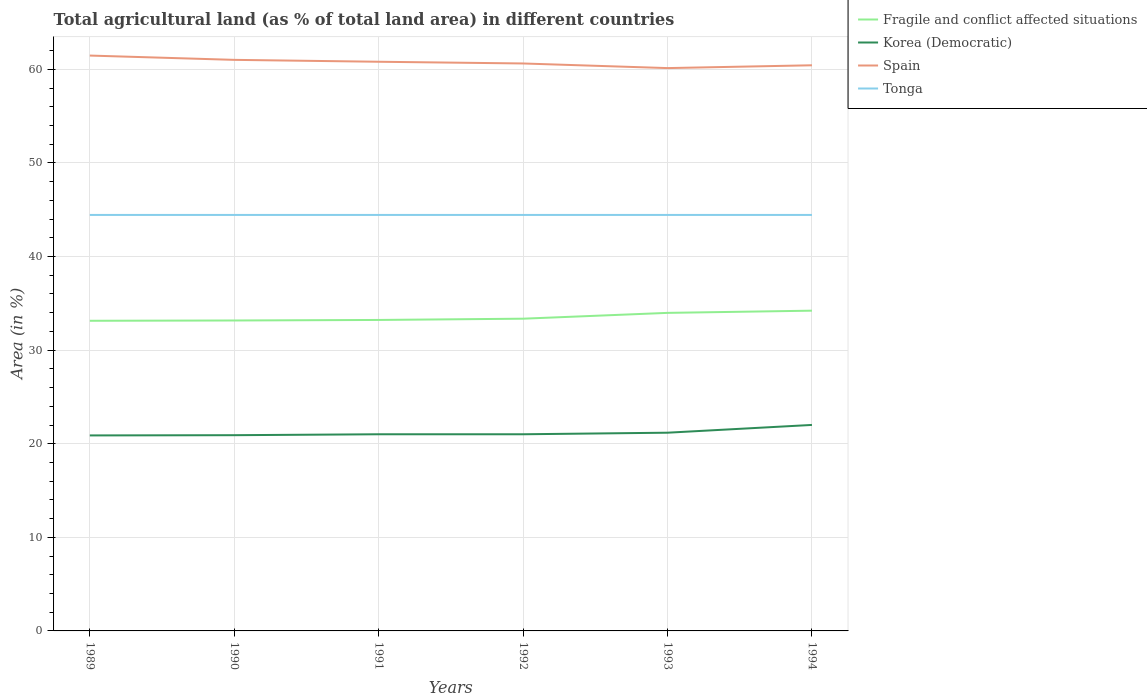Does the line corresponding to Tonga intersect with the line corresponding to Korea (Democratic)?
Keep it short and to the point. No. Is the number of lines equal to the number of legend labels?
Keep it short and to the point. Yes. Across all years, what is the maximum percentage of agricultural land in Fragile and conflict affected situations?
Ensure brevity in your answer.  33.13. In which year was the percentage of agricultural land in Fragile and conflict affected situations maximum?
Your response must be concise. 1989. What is the total percentage of agricultural land in Korea (Democratic) in the graph?
Give a very brief answer. -0.29. What is the difference between the highest and the second highest percentage of agricultural land in Tonga?
Your answer should be compact. 0. Is the percentage of agricultural land in Fragile and conflict affected situations strictly greater than the percentage of agricultural land in Korea (Democratic) over the years?
Provide a short and direct response. No. Are the values on the major ticks of Y-axis written in scientific E-notation?
Keep it short and to the point. No. Does the graph contain any zero values?
Keep it short and to the point. No. How many legend labels are there?
Keep it short and to the point. 4. What is the title of the graph?
Provide a succinct answer. Total agricultural land (as % of total land area) in different countries. Does "Central Europe" appear as one of the legend labels in the graph?
Your answer should be very brief. No. What is the label or title of the X-axis?
Ensure brevity in your answer.  Years. What is the label or title of the Y-axis?
Provide a succinct answer. Area (in %). What is the Area (in %) in Fragile and conflict affected situations in 1989?
Your response must be concise. 33.13. What is the Area (in %) in Korea (Democratic) in 1989?
Keep it short and to the point. 20.89. What is the Area (in %) in Spain in 1989?
Provide a succinct answer. 61.47. What is the Area (in %) of Tonga in 1989?
Offer a terse response. 44.44. What is the Area (in %) of Fragile and conflict affected situations in 1990?
Provide a short and direct response. 33.17. What is the Area (in %) in Korea (Democratic) in 1990?
Your answer should be compact. 20.91. What is the Area (in %) in Spain in 1990?
Your response must be concise. 61.01. What is the Area (in %) in Tonga in 1990?
Your answer should be compact. 44.44. What is the Area (in %) of Fragile and conflict affected situations in 1991?
Your response must be concise. 33.22. What is the Area (in %) in Korea (Democratic) in 1991?
Keep it short and to the point. 21.01. What is the Area (in %) in Spain in 1991?
Your response must be concise. 60.81. What is the Area (in %) in Tonga in 1991?
Offer a terse response. 44.44. What is the Area (in %) of Fragile and conflict affected situations in 1992?
Provide a short and direct response. 33.36. What is the Area (in %) in Korea (Democratic) in 1992?
Provide a short and direct response. 21.01. What is the Area (in %) of Spain in 1992?
Give a very brief answer. 60.63. What is the Area (in %) of Tonga in 1992?
Offer a terse response. 44.44. What is the Area (in %) in Fragile and conflict affected situations in 1993?
Provide a short and direct response. 33.98. What is the Area (in %) in Korea (Democratic) in 1993?
Your answer should be very brief. 21.18. What is the Area (in %) of Spain in 1993?
Offer a very short reply. 60.13. What is the Area (in %) in Tonga in 1993?
Make the answer very short. 44.44. What is the Area (in %) in Fragile and conflict affected situations in 1994?
Make the answer very short. 34.21. What is the Area (in %) of Korea (Democratic) in 1994?
Keep it short and to the point. 22.01. What is the Area (in %) of Spain in 1994?
Ensure brevity in your answer.  60.43. What is the Area (in %) of Tonga in 1994?
Offer a terse response. 44.44. Across all years, what is the maximum Area (in %) in Fragile and conflict affected situations?
Provide a short and direct response. 34.21. Across all years, what is the maximum Area (in %) of Korea (Democratic)?
Ensure brevity in your answer.  22.01. Across all years, what is the maximum Area (in %) in Spain?
Ensure brevity in your answer.  61.47. Across all years, what is the maximum Area (in %) in Tonga?
Keep it short and to the point. 44.44. Across all years, what is the minimum Area (in %) in Fragile and conflict affected situations?
Offer a terse response. 33.13. Across all years, what is the minimum Area (in %) of Korea (Democratic)?
Ensure brevity in your answer.  20.89. Across all years, what is the minimum Area (in %) of Spain?
Give a very brief answer. 60.13. Across all years, what is the minimum Area (in %) in Tonga?
Ensure brevity in your answer.  44.44. What is the total Area (in %) in Fragile and conflict affected situations in the graph?
Your answer should be compact. 201.08. What is the total Area (in %) in Korea (Democratic) in the graph?
Your response must be concise. 127.01. What is the total Area (in %) in Spain in the graph?
Provide a succinct answer. 364.49. What is the total Area (in %) of Tonga in the graph?
Your answer should be compact. 266.67. What is the difference between the Area (in %) of Fragile and conflict affected situations in 1989 and that in 1990?
Your answer should be compact. -0.03. What is the difference between the Area (in %) of Korea (Democratic) in 1989 and that in 1990?
Provide a short and direct response. -0.02. What is the difference between the Area (in %) of Spain in 1989 and that in 1990?
Provide a succinct answer. 0.46. What is the difference between the Area (in %) in Fragile and conflict affected situations in 1989 and that in 1991?
Offer a very short reply. -0.09. What is the difference between the Area (in %) in Korea (Democratic) in 1989 and that in 1991?
Offer a very short reply. -0.12. What is the difference between the Area (in %) in Spain in 1989 and that in 1991?
Ensure brevity in your answer.  0.66. What is the difference between the Area (in %) in Fragile and conflict affected situations in 1989 and that in 1992?
Keep it short and to the point. -0.22. What is the difference between the Area (in %) of Korea (Democratic) in 1989 and that in 1992?
Offer a very short reply. -0.12. What is the difference between the Area (in %) of Spain in 1989 and that in 1992?
Make the answer very short. 0.84. What is the difference between the Area (in %) in Fragile and conflict affected situations in 1989 and that in 1993?
Provide a short and direct response. -0.84. What is the difference between the Area (in %) of Korea (Democratic) in 1989 and that in 1993?
Offer a very short reply. -0.29. What is the difference between the Area (in %) of Spain in 1989 and that in 1993?
Give a very brief answer. 1.34. What is the difference between the Area (in %) in Tonga in 1989 and that in 1993?
Your answer should be compact. 0. What is the difference between the Area (in %) in Fragile and conflict affected situations in 1989 and that in 1994?
Offer a very short reply. -1.08. What is the difference between the Area (in %) of Korea (Democratic) in 1989 and that in 1994?
Offer a terse response. -1.12. What is the difference between the Area (in %) in Spain in 1989 and that in 1994?
Offer a terse response. 1.04. What is the difference between the Area (in %) of Tonga in 1989 and that in 1994?
Provide a short and direct response. 0. What is the difference between the Area (in %) of Fragile and conflict affected situations in 1990 and that in 1991?
Give a very brief answer. -0.06. What is the difference between the Area (in %) of Korea (Democratic) in 1990 and that in 1991?
Make the answer very short. -0.1. What is the difference between the Area (in %) of Spain in 1990 and that in 1991?
Provide a short and direct response. 0.2. What is the difference between the Area (in %) of Fragile and conflict affected situations in 1990 and that in 1992?
Make the answer very short. -0.19. What is the difference between the Area (in %) of Korea (Democratic) in 1990 and that in 1992?
Make the answer very short. -0.1. What is the difference between the Area (in %) in Spain in 1990 and that in 1992?
Make the answer very short. 0.39. What is the difference between the Area (in %) of Tonga in 1990 and that in 1992?
Give a very brief answer. 0. What is the difference between the Area (in %) in Fragile and conflict affected situations in 1990 and that in 1993?
Offer a terse response. -0.81. What is the difference between the Area (in %) of Korea (Democratic) in 1990 and that in 1993?
Provide a short and direct response. -0.27. What is the difference between the Area (in %) in Spain in 1990 and that in 1993?
Keep it short and to the point. 0.88. What is the difference between the Area (in %) of Tonga in 1990 and that in 1993?
Offer a terse response. 0. What is the difference between the Area (in %) in Fragile and conflict affected situations in 1990 and that in 1994?
Give a very brief answer. -1.05. What is the difference between the Area (in %) in Korea (Democratic) in 1990 and that in 1994?
Keep it short and to the point. -1.1. What is the difference between the Area (in %) in Spain in 1990 and that in 1994?
Offer a terse response. 0.58. What is the difference between the Area (in %) of Fragile and conflict affected situations in 1991 and that in 1992?
Your answer should be very brief. -0.14. What is the difference between the Area (in %) of Korea (Democratic) in 1991 and that in 1992?
Provide a short and direct response. 0. What is the difference between the Area (in %) of Spain in 1991 and that in 1992?
Your answer should be very brief. 0.18. What is the difference between the Area (in %) of Fragile and conflict affected situations in 1991 and that in 1993?
Your answer should be compact. -0.76. What is the difference between the Area (in %) in Korea (Democratic) in 1991 and that in 1993?
Keep it short and to the point. -0.17. What is the difference between the Area (in %) in Spain in 1991 and that in 1993?
Provide a short and direct response. 0.68. What is the difference between the Area (in %) in Fragile and conflict affected situations in 1991 and that in 1994?
Keep it short and to the point. -0.99. What is the difference between the Area (in %) of Korea (Democratic) in 1991 and that in 1994?
Offer a terse response. -1. What is the difference between the Area (in %) of Spain in 1991 and that in 1994?
Keep it short and to the point. 0.38. What is the difference between the Area (in %) of Fragile and conflict affected situations in 1992 and that in 1993?
Your answer should be very brief. -0.62. What is the difference between the Area (in %) in Korea (Democratic) in 1992 and that in 1993?
Provide a succinct answer. -0.17. What is the difference between the Area (in %) in Spain in 1992 and that in 1993?
Provide a short and direct response. 0.49. What is the difference between the Area (in %) in Fragile and conflict affected situations in 1992 and that in 1994?
Your response must be concise. -0.86. What is the difference between the Area (in %) in Korea (Democratic) in 1992 and that in 1994?
Ensure brevity in your answer.  -1. What is the difference between the Area (in %) in Spain in 1992 and that in 1994?
Provide a succinct answer. 0.19. What is the difference between the Area (in %) of Tonga in 1992 and that in 1994?
Offer a very short reply. 0. What is the difference between the Area (in %) of Fragile and conflict affected situations in 1993 and that in 1994?
Your response must be concise. -0.24. What is the difference between the Area (in %) of Korea (Democratic) in 1993 and that in 1994?
Provide a succinct answer. -0.83. What is the difference between the Area (in %) in Spain in 1993 and that in 1994?
Provide a succinct answer. -0.3. What is the difference between the Area (in %) in Tonga in 1993 and that in 1994?
Keep it short and to the point. 0. What is the difference between the Area (in %) of Fragile and conflict affected situations in 1989 and the Area (in %) of Korea (Democratic) in 1990?
Offer a very short reply. 12.22. What is the difference between the Area (in %) in Fragile and conflict affected situations in 1989 and the Area (in %) in Spain in 1990?
Make the answer very short. -27.88. What is the difference between the Area (in %) in Fragile and conflict affected situations in 1989 and the Area (in %) in Tonga in 1990?
Give a very brief answer. -11.31. What is the difference between the Area (in %) of Korea (Democratic) in 1989 and the Area (in %) of Spain in 1990?
Offer a terse response. -40.13. What is the difference between the Area (in %) of Korea (Democratic) in 1989 and the Area (in %) of Tonga in 1990?
Offer a terse response. -23.56. What is the difference between the Area (in %) of Spain in 1989 and the Area (in %) of Tonga in 1990?
Keep it short and to the point. 17.03. What is the difference between the Area (in %) in Fragile and conflict affected situations in 1989 and the Area (in %) in Korea (Democratic) in 1991?
Your response must be concise. 12.12. What is the difference between the Area (in %) of Fragile and conflict affected situations in 1989 and the Area (in %) of Spain in 1991?
Make the answer very short. -27.68. What is the difference between the Area (in %) of Fragile and conflict affected situations in 1989 and the Area (in %) of Tonga in 1991?
Provide a succinct answer. -11.31. What is the difference between the Area (in %) in Korea (Democratic) in 1989 and the Area (in %) in Spain in 1991?
Keep it short and to the point. -39.92. What is the difference between the Area (in %) in Korea (Democratic) in 1989 and the Area (in %) in Tonga in 1991?
Give a very brief answer. -23.56. What is the difference between the Area (in %) in Spain in 1989 and the Area (in %) in Tonga in 1991?
Give a very brief answer. 17.03. What is the difference between the Area (in %) in Fragile and conflict affected situations in 1989 and the Area (in %) in Korea (Democratic) in 1992?
Offer a terse response. 12.12. What is the difference between the Area (in %) in Fragile and conflict affected situations in 1989 and the Area (in %) in Spain in 1992?
Provide a succinct answer. -27.49. What is the difference between the Area (in %) of Fragile and conflict affected situations in 1989 and the Area (in %) of Tonga in 1992?
Your response must be concise. -11.31. What is the difference between the Area (in %) in Korea (Democratic) in 1989 and the Area (in %) in Spain in 1992?
Your response must be concise. -39.74. What is the difference between the Area (in %) in Korea (Democratic) in 1989 and the Area (in %) in Tonga in 1992?
Ensure brevity in your answer.  -23.56. What is the difference between the Area (in %) in Spain in 1989 and the Area (in %) in Tonga in 1992?
Keep it short and to the point. 17.03. What is the difference between the Area (in %) of Fragile and conflict affected situations in 1989 and the Area (in %) of Korea (Democratic) in 1993?
Your answer should be very brief. 11.96. What is the difference between the Area (in %) of Fragile and conflict affected situations in 1989 and the Area (in %) of Spain in 1993?
Make the answer very short. -27. What is the difference between the Area (in %) in Fragile and conflict affected situations in 1989 and the Area (in %) in Tonga in 1993?
Provide a short and direct response. -11.31. What is the difference between the Area (in %) of Korea (Democratic) in 1989 and the Area (in %) of Spain in 1993?
Your answer should be compact. -39.25. What is the difference between the Area (in %) of Korea (Democratic) in 1989 and the Area (in %) of Tonga in 1993?
Offer a terse response. -23.56. What is the difference between the Area (in %) in Spain in 1989 and the Area (in %) in Tonga in 1993?
Provide a succinct answer. 17.03. What is the difference between the Area (in %) in Fragile and conflict affected situations in 1989 and the Area (in %) in Korea (Democratic) in 1994?
Provide a succinct answer. 11.13. What is the difference between the Area (in %) in Fragile and conflict affected situations in 1989 and the Area (in %) in Spain in 1994?
Offer a very short reply. -27.3. What is the difference between the Area (in %) of Fragile and conflict affected situations in 1989 and the Area (in %) of Tonga in 1994?
Ensure brevity in your answer.  -11.31. What is the difference between the Area (in %) of Korea (Democratic) in 1989 and the Area (in %) of Spain in 1994?
Keep it short and to the point. -39.55. What is the difference between the Area (in %) in Korea (Democratic) in 1989 and the Area (in %) in Tonga in 1994?
Offer a terse response. -23.56. What is the difference between the Area (in %) of Spain in 1989 and the Area (in %) of Tonga in 1994?
Give a very brief answer. 17.03. What is the difference between the Area (in %) in Fragile and conflict affected situations in 1990 and the Area (in %) in Korea (Democratic) in 1991?
Offer a terse response. 12.16. What is the difference between the Area (in %) in Fragile and conflict affected situations in 1990 and the Area (in %) in Spain in 1991?
Keep it short and to the point. -27.64. What is the difference between the Area (in %) in Fragile and conflict affected situations in 1990 and the Area (in %) in Tonga in 1991?
Make the answer very short. -11.28. What is the difference between the Area (in %) of Korea (Democratic) in 1990 and the Area (in %) of Spain in 1991?
Keep it short and to the point. -39.9. What is the difference between the Area (in %) of Korea (Democratic) in 1990 and the Area (in %) of Tonga in 1991?
Provide a short and direct response. -23.53. What is the difference between the Area (in %) in Spain in 1990 and the Area (in %) in Tonga in 1991?
Offer a very short reply. 16.57. What is the difference between the Area (in %) of Fragile and conflict affected situations in 1990 and the Area (in %) of Korea (Democratic) in 1992?
Offer a very short reply. 12.16. What is the difference between the Area (in %) in Fragile and conflict affected situations in 1990 and the Area (in %) in Spain in 1992?
Ensure brevity in your answer.  -27.46. What is the difference between the Area (in %) of Fragile and conflict affected situations in 1990 and the Area (in %) of Tonga in 1992?
Offer a very short reply. -11.28. What is the difference between the Area (in %) of Korea (Democratic) in 1990 and the Area (in %) of Spain in 1992?
Your answer should be very brief. -39.71. What is the difference between the Area (in %) of Korea (Democratic) in 1990 and the Area (in %) of Tonga in 1992?
Provide a succinct answer. -23.53. What is the difference between the Area (in %) of Spain in 1990 and the Area (in %) of Tonga in 1992?
Offer a terse response. 16.57. What is the difference between the Area (in %) in Fragile and conflict affected situations in 1990 and the Area (in %) in Korea (Democratic) in 1993?
Your answer should be very brief. 11.99. What is the difference between the Area (in %) of Fragile and conflict affected situations in 1990 and the Area (in %) of Spain in 1993?
Your answer should be very brief. -26.97. What is the difference between the Area (in %) of Fragile and conflict affected situations in 1990 and the Area (in %) of Tonga in 1993?
Give a very brief answer. -11.28. What is the difference between the Area (in %) of Korea (Democratic) in 1990 and the Area (in %) of Spain in 1993?
Make the answer very short. -39.22. What is the difference between the Area (in %) in Korea (Democratic) in 1990 and the Area (in %) in Tonga in 1993?
Provide a short and direct response. -23.53. What is the difference between the Area (in %) of Spain in 1990 and the Area (in %) of Tonga in 1993?
Your answer should be very brief. 16.57. What is the difference between the Area (in %) of Fragile and conflict affected situations in 1990 and the Area (in %) of Korea (Democratic) in 1994?
Keep it short and to the point. 11.16. What is the difference between the Area (in %) of Fragile and conflict affected situations in 1990 and the Area (in %) of Spain in 1994?
Offer a terse response. -27.27. What is the difference between the Area (in %) in Fragile and conflict affected situations in 1990 and the Area (in %) in Tonga in 1994?
Ensure brevity in your answer.  -11.28. What is the difference between the Area (in %) in Korea (Democratic) in 1990 and the Area (in %) in Spain in 1994?
Ensure brevity in your answer.  -39.52. What is the difference between the Area (in %) of Korea (Democratic) in 1990 and the Area (in %) of Tonga in 1994?
Offer a very short reply. -23.53. What is the difference between the Area (in %) in Spain in 1990 and the Area (in %) in Tonga in 1994?
Your answer should be compact. 16.57. What is the difference between the Area (in %) in Fragile and conflict affected situations in 1991 and the Area (in %) in Korea (Democratic) in 1992?
Provide a succinct answer. 12.21. What is the difference between the Area (in %) in Fragile and conflict affected situations in 1991 and the Area (in %) in Spain in 1992?
Your answer should be compact. -27.4. What is the difference between the Area (in %) in Fragile and conflict affected situations in 1991 and the Area (in %) in Tonga in 1992?
Keep it short and to the point. -11.22. What is the difference between the Area (in %) in Korea (Democratic) in 1991 and the Area (in %) in Spain in 1992?
Offer a terse response. -39.61. What is the difference between the Area (in %) of Korea (Democratic) in 1991 and the Area (in %) of Tonga in 1992?
Your answer should be very brief. -23.43. What is the difference between the Area (in %) of Spain in 1991 and the Area (in %) of Tonga in 1992?
Your answer should be very brief. 16.37. What is the difference between the Area (in %) in Fragile and conflict affected situations in 1991 and the Area (in %) in Korea (Democratic) in 1993?
Give a very brief answer. 12.05. What is the difference between the Area (in %) of Fragile and conflict affected situations in 1991 and the Area (in %) of Spain in 1993?
Your answer should be very brief. -26.91. What is the difference between the Area (in %) in Fragile and conflict affected situations in 1991 and the Area (in %) in Tonga in 1993?
Your answer should be compact. -11.22. What is the difference between the Area (in %) of Korea (Democratic) in 1991 and the Area (in %) of Spain in 1993?
Keep it short and to the point. -39.12. What is the difference between the Area (in %) in Korea (Democratic) in 1991 and the Area (in %) in Tonga in 1993?
Offer a terse response. -23.43. What is the difference between the Area (in %) of Spain in 1991 and the Area (in %) of Tonga in 1993?
Offer a very short reply. 16.37. What is the difference between the Area (in %) of Fragile and conflict affected situations in 1991 and the Area (in %) of Korea (Democratic) in 1994?
Give a very brief answer. 11.22. What is the difference between the Area (in %) in Fragile and conflict affected situations in 1991 and the Area (in %) in Spain in 1994?
Provide a short and direct response. -27.21. What is the difference between the Area (in %) in Fragile and conflict affected situations in 1991 and the Area (in %) in Tonga in 1994?
Offer a terse response. -11.22. What is the difference between the Area (in %) of Korea (Democratic) in 1991 and the Area (in %) of Spain in 1994?
Your answer should be very brief. -39.42. What is the difference between the Area (in %) in Korea (Democratic) in 1991 and the Area (in %) in Tonga in 1994?
Ensure brevity in your answer.  -23.43. What is the difference between the Area (in %) of Spain in 1991 and the Area (in %) of Tonga in 1994?
Make the answer very short. 16.37. What is the difference between the Area (in %) of Fragile and conflict affected situations in 1992 and the Area (in %) of Korea (Democratic) in 1993?
Your answer should be very brief. 12.18. What is the difference between the Area (in %) of Fragile and conflict affected situations in 1992 and the Area (in %) of Spain in 1993?
Provide a short and direct response. -26.77. What is the difference between the Area (in %) of Fragile and conflict affected situations in 1992 and the Area (in %) of Tonga in 1993?
Offer a terse response. -11.09. What is the difference between the Area (in %) of Korea (Democratic) in 1992 and the Area (in %) of Spain in 1993?
Offer a very short reply. -39.12. What is the difference between the Area (in %) in Korea (Democratic) in 1992 and the Area (in %) in Tonga in 1993?
Offer a terse response. -23.43. What is the difference between the Area (in %) in Spain in 1992 and the Area (in %) in Tonga in 1993?
Provide a succinct answer. 16.18. What is the difference between the Area (in %) in Fragile and conflict affected situations in 1992 and the Area (in %) in Korea (Democratic) in 1994?
Provide a succinct answer. 11.35. What is the difference between the Area (in %) in Fragile and conflict affected situations in 1992 and the Area (in %) in Spain in 1994?
Make the answer very short. -27.07. What is the difference between the Area (in %) in Fragile and conflict affected situations in 1992 and the Area (in %) in Tonga in 1994?
Give a very brief answer. -11.09. What is the difference between the Area (in %) of Korea (Democratic) in 1992 and the Area (in %) of Spain in 1994?
Give a very brief answer. -39.42. What is the difference between the Area (in %) of Korea (Democratic) in 1992 and the Area (in %) of Tonga in 1994?
Make the answer very short. -23.43. What is the difference between the Area (in %) in Spain in 1992 and the Area (in %) in Tonga in 1994?
Offer a terse response. 16.18. What is the difference between the Area (in %) of Fragile and conflict affected situations in 1993 and the Area (in %) of Korea (Democratic) in 1994?
Ensure brevity in your answer.  11.97. What is the difference between the Area (in %) in Fragile and conflict affected situations in 1993 and the Area (in %) in Spain in 1994?
Provide a short and direct response. -26.45. What is the difference between the Area (in %) in Fragile and conflict affected situations in 1993 and the Area (in %) in Tonga in 1994?
Provide a short and direct response. -10.46. What is the difference between the Area (in %) of Korea (Democratic) in 1993 and the Area (in %) of Spain in 1994?
Keep it short and to the point. -39.26. What is the difference between the Area (in %) of Korea (Democratic) in 1993 and the Area (in %) of Tonga in 1994?
Provide a short and direct response. -23.27. What is the difference between the Area (in %) in Spain in 1993 and the Area (in %) in Tonga in 1994?
Your answer should be compact. 15.69. What is the average Area (in %) of Fragile and conflict affected situations per year?
Offer a very short reply. 33.51. What is the average Area (in %) of Korea (Democratic) per year?
Offer a terse response. 21.17. What is the average Area (in %) in Spain per year?
Provide a short and direct response. 60.75. What is the average Area (in %) in Tonga per year?
Your response must be concise. 44.44. In the year 1989, what is the difference between the Area (in %) of Fragile and conflict affected situations and Area (in %) of Korea (Democratic)?
Make the answer very short. 12.25. In the year 1989, what is the difference between the Area (in %) in Fragile and conflict affected situations and Area (in %) in Spain?
Provide a short and direct response. -28.34. In the year 1989, what is the difference between the Area (in %) in Fragile and conflict affected situations and Area (in %) in Tonga?
Provide a succinct answer. -11.31. In the year 1989, what is the difference between the Area (in %) of Korea (Democratic) and Area (in %) of Spain?
Offer a terse response. -40.58. In the year 1989, what is the difference between the Area (in %) of Korea (Democratic) and Area (in %) of Tonga?
Keep it short and to the point. -23.56. In the year 1989, what is the difference between the Area (in %) in Spain and Area (in %) in Tonga?
Keep it short and to the point. 17.03. In the year 1990, what is the difference between the Area (in %) in Fragile and conflict affected situations and Area (in %) in Korea (Democratic)?
Your answer should be very brief. 12.26. In the year 1990, what is the difference between the Area (in %) of Fragile and conflict affected situations and Area (in %) of Spain?
Your answer should be compact. -27.84. In the year 1990, what is the difference between the Area (in %) of Fragile and conflict affected situations and Area (in %) of Tonga?
Your answer should be compact. -11.28. In the year 1990, what is the difference between the Area (in %) of Korea (Democratic) and Area (in %) of Spain?
Keep it short and to the point. -40.1. In the year 1990, what is the difference between the Area (in %) of Korea (Democratic) and Area (in %) of Tonga?
Your answer should be very brief. -23.53. In the year 1990, what is the difference between the Area (in %) of Spain and Area (in %) of Tonga?
Offer a terse response. 16.57. In the year 1991, what is the difference between the Area (in %) of Fragile and conflict affected situations and Area (in %) of Korea (Democratic)?
Ensure brevity in your answer.  12.21. In the year 1991, what is the difference between the Area (in %) in Fragile and conflict affected situations and Area (in %) in Spain?
Your answer should be very brief. -27.59. In the year 1991, what is the difference between the Area (in %) in Fragile and conflict affected situations and Area (in %) in Tonga?
Make the answer very short. -11.22. In the year 1991, what is the difference between the Area (in %) in Korea (Democratic) and Area (in %) in Spain?
Offer a very short reply. -39.8. In the year 1991, what is the difference between the Area (in %) of Korea (Democratic) and Area (in %) of Tonga?
Keep it short and to the point. -23.43. In the year 1991, what is the difference between the Area (in %) of Spain and Area (in %) of Tonga?
Provide a succinct answer. 16.37. In the year 1992, what is the difference between the Area (in %) of Fragile and conflict affected situations and Area (in %) of Korea (Democratic)?
Provide a succinct answer. 12.35. In the year 1992, what is the difference between the Area (in %) in Fragile and conflict affected situations and Area (in %) in Spain?
Make the answer very short. -27.27. In the year 1992, what is the difference between the Area (in %) in Fragile and conflict affected situations and Area (in %) in Tonga?
Make the answer very short. -11.09. In the year 1992, what is the difference between the Area (in %) of Korea (Democratic) and Area (in %) of Spain?
Offer a very short reply. -39.61. In the year 1992, what is the difference between the Area (in %) of Korea (Democratic) and Area (in %) of Tonga?
Keep it short and to the point. -23.43. In the year 1992, what is the difference between the Area (in %) in Spain and Area (in %) in Tonga?
Keep it short and to the point. 16.18. In the year 1993, what is the difference between the Area (in %) in Fragile and conflict affected situations and Area (in %) in Korea (Democratic)?
Make the answer very short. 12.8. In the year 1993, what is the difference between the Area (in %) in Fragile and conflict affected situations and Area (in %) in Spain?
Offer a terse response. -26.15. In the year 1993, what is the difference between the Area (in %) of Fragile and conflict affected situations and Area (in %) of Tonga?
Keep it short and to the point. -10.46. In the year 1993, what is the difference between the Area (in %) in Korea (Democratic) and Area (in %) in Spain?
Offer a terse response. -38.96. In the year 1993, what is the difference between the Area (in %) of Korea (Democratic) and Area (in %) of Tonga?
Your answer should be very brief. -23.27. In the year 1993, what is the difference between the Area (in %) of Spain and Area (in %) of Tonga?
Give a very brief answer. 15.69. In the year 1994, what is the difference between the Area (in %) in Fragile and conflict affected situations and Area (in %) in Korea (Democratic)?
Offer a terse response. 12.21. In the year 1994, what is the difference between the Area (in %) of Fragile and conflict affected situations and Area (in %) of Spain?
Your response must be concise. -26.22. In the year 1994, what is the difference between the Area (in %) in Fragile and conflict affected situations and Area (in %) in Tonga?
Your response must be concise. -10.23. In the year 1994, what is the difference between the Area (in %) in Korea (Democratic) and Area (in %) in Spain?
Offer a terse response. -38.43. In the year 1994, what is the difference between the Area (in %) in Korea (Democratic) and Area (in %) in Tonga?
Provide a succinct answer. -22.44. In the year 1994, what is the difference between the Area (in %) of Spain and Area (in %) of Tonga?
Provide a short and direct response. 15.99. What is the ratio of the Area (in %) in Fragile and conflict affected situations in 1989 to that in 1990?
Your answer should be very brief. 1. What is the ratio of the Area (in %) of Spain in 1989 to that in 1990?
Your answer should be very brief. 1.01. What is the ratio of the Area (in %) in Fragile and conflict affected situations in 1989 to that in 1991?
Make the answer very short. 1. What is the ratio of the Area (in %) in Spain in 1989 to that in 1991?
Provide a short and direct response. 1.01. What is the ratio of the Area (in %) of Tonga in 1989 to that in 1991?
Offer a very short reply. 1. What is the ratio of the Area (in %) of Korea (Democratic) in 1989 to that in 1992?
Offer a very short reply. 0.99. What is the ratio of the Area (in %) of Spain in 1989 to that in 1992?
Give a very brief answer. 1.01. What is the ratio of the Area (in %) in Fragile and conflict affected situations in 1989 to that in 1993?
Offer a very short reply. 0.98. What is the ratio of the Area (in %) in Korea (Democratic) in 1989 to that in 1993?
Make the answer very short. 0.99. What is the ratio of the Area (in %) of Spain in 1989 to that in 1993?
Provide a succinct answer. 1.02. What is the ratio of the Area (in %) in Tonga in 1989 to that in 1993?
Make the answer very short. 1. What is the ratio of the Area (in %) in Fragile and conflict affected situations in 1989 to that in 1994?
Make the answer very short. 0.97. What is the ratio of the Area (in %) in Korea (Democratic) in 1989 to that in 1994?
Offer a very short reply. 0.95. What is the ratio of the Area (in %) of Spain in 1989 to that in 1994?
Make the answer very short. 1.02. What is the ratio of the Area (in %) of Tonga in 1989 to that in 1994?
Your answer should be compact. 1. What is the ratio of the Area (in %) of Fragile and conflict affected situations in 1990 to that in 1991?
Provide a succinct answer. 1. What is the ratio of the Area (in %) in Korea (Democratic) in 1990 to that in 1991?
Give a very brief answer. 1. What is the ratio of the Area (in %) of Spain in 1990 to that in 1991?
Your answer should be very brief. 1. What is the ratio of the Area (in %) in Tonga in 1990 to that in 1991?
Your response must be concise. 1. What is the ratio of the Area (in %) in Spain in 1990 to that in 1992?
Provide a succinct answer. 1.01. What is the ratio of the Area (in %) of Fragile and conflict affected situations in 1990 to that in 1993?
Your answer should be very brief. 0.98. What is the ratio of the Area (in %) of Korea (Democratic) in 1990 to that in 1993?
Make the answer very short. 0.99. What is the ratio of the Area (in %) in Spain in 1990 to that in 1993?
Give a very brief answer. 1.01. What is the ratio of the Area (in %) of Fragile and conflict affected situations in 1990 to that in 1994?
Give a very brief answer. 0.97. What is the ratio of the Area (in %) of Korea (Democratic) in 1990 to that in 1994?
Offer a terse response. 0.95. What is the ratio of the Area (in %) of Spain in 1990 to that in 1994?
Offer a very short reply. 1.01. What is the ratio of the Area (in %) of Tonga in 1990 to that in 1994?
Keep it short and to the point. 1. What is the ratio of the Area (in %) of Korea (Democratic) in 1991 to that in 1992?
Keep it short and to the point. 1. What is the ratio of the Area (in %) in Tonga in 1991 to that in 1992?
Ensure brevity in your answer.  1. What is the ratio of the Area (in %) in Fragile and conflict affected situations in 1991 to that in 1993?
Offer a very short reply. 0.98. What is the ratio of the Area (in %) in Spain in 1991 to that in 1993?
Your answer should be very brief. 1.01. What is the ratio of the Area (in %) in Tonga in 1991 to that in 1993?
Your answer should be compact. 1. What is the ratio of the Area (in %) in Fragile and conflict affected situations in 1991 to that in 1994?
Give a very brief answer. 0.97. What is the ratio of the Area (in %) of Korea (Democratic) in 1991 to that in 1994?
Keep it short and to the point. 0.95. What is the ratio of the Area (in %) of Spain in 1991 to that in 1994?
Give a very brief answer. 1.01. What is the ratio of the Area (in %) in Fragile and conflict affected situations in 1992 to that in 1993?
Keep it short and to the point. 0.98. What is the ratio of the Area (in %) in Korea (Democratic) in 1992 to that in 1993?
Keep it short and to the point. 0.99. What is the ratio of the Area (in %) of Spain in 1992 to that in 1993?
Make the answer very short. 1.01. What is the ratio of the Area (in %) of Tonga in 1992 to that in 1993?
Your answer should be very brief. 1. What is the ratio of the Area (in %) in Korea (Democratic) in 1992 to that in 1994?
Your response must be concise. 0.95. What is the ratio of the Area (in %) in Spain in 1992 to that in 1994?
Ensure brevity in your answer.  1. What is the ratio of the Area (in %) of Fragile and conflict affected situations in 1993 to that in 1994?
Provide a short and direct response. 0.99. What is the ratio of the Area (in %) in Korea (Democratic) in 1993 to that in 1994?
Keep it short and to the point. 0.96. What is the ratio of the Area (in %) in Spain in 1993 to that in 1994?
Ensure brevity in your answer.  0.99. What is the difference between the highest and the second highest Area (in %) of Fragile and conflict affected situations?
Keep it short and to the point. 0.24. What is the difference between the highest and the second highest Area (in %) of Korea (Democratic)?
Provide a succinct answer. 0.83. What is the difference between the highest and the second highest Area (in %) in Spain?
Offer a terse response. 0.46. What is the difference between the highest and the lowest Area (in %) of Fragile and conflict affected situations?
Offer a very short reply. 1.08. What is the difference between the highest and the lowest Area (in %) of Korea (Democratic)?
Keep it short and to the point. 1.12. What is the difference between the highest and the lowest Area (in %) of Spain?
Your answer should be compact. 1.34. 